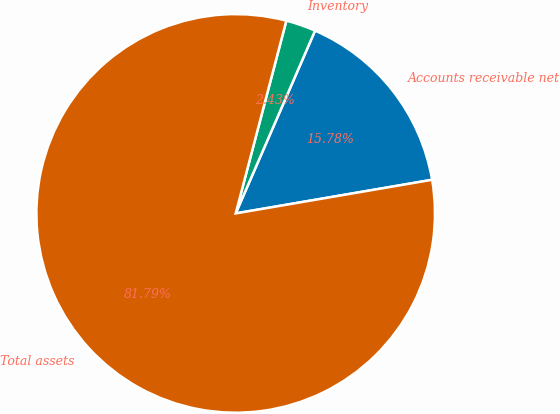<chart> <loc_0><loc_0><loc_500><loc_500><pie_chart><fcel>Accounts receivable net<fcel>Inventory<fcel>Total assets<nl><fcel>15.78%<fcel>2.43%<fcel>81.79%<nl></chart> 